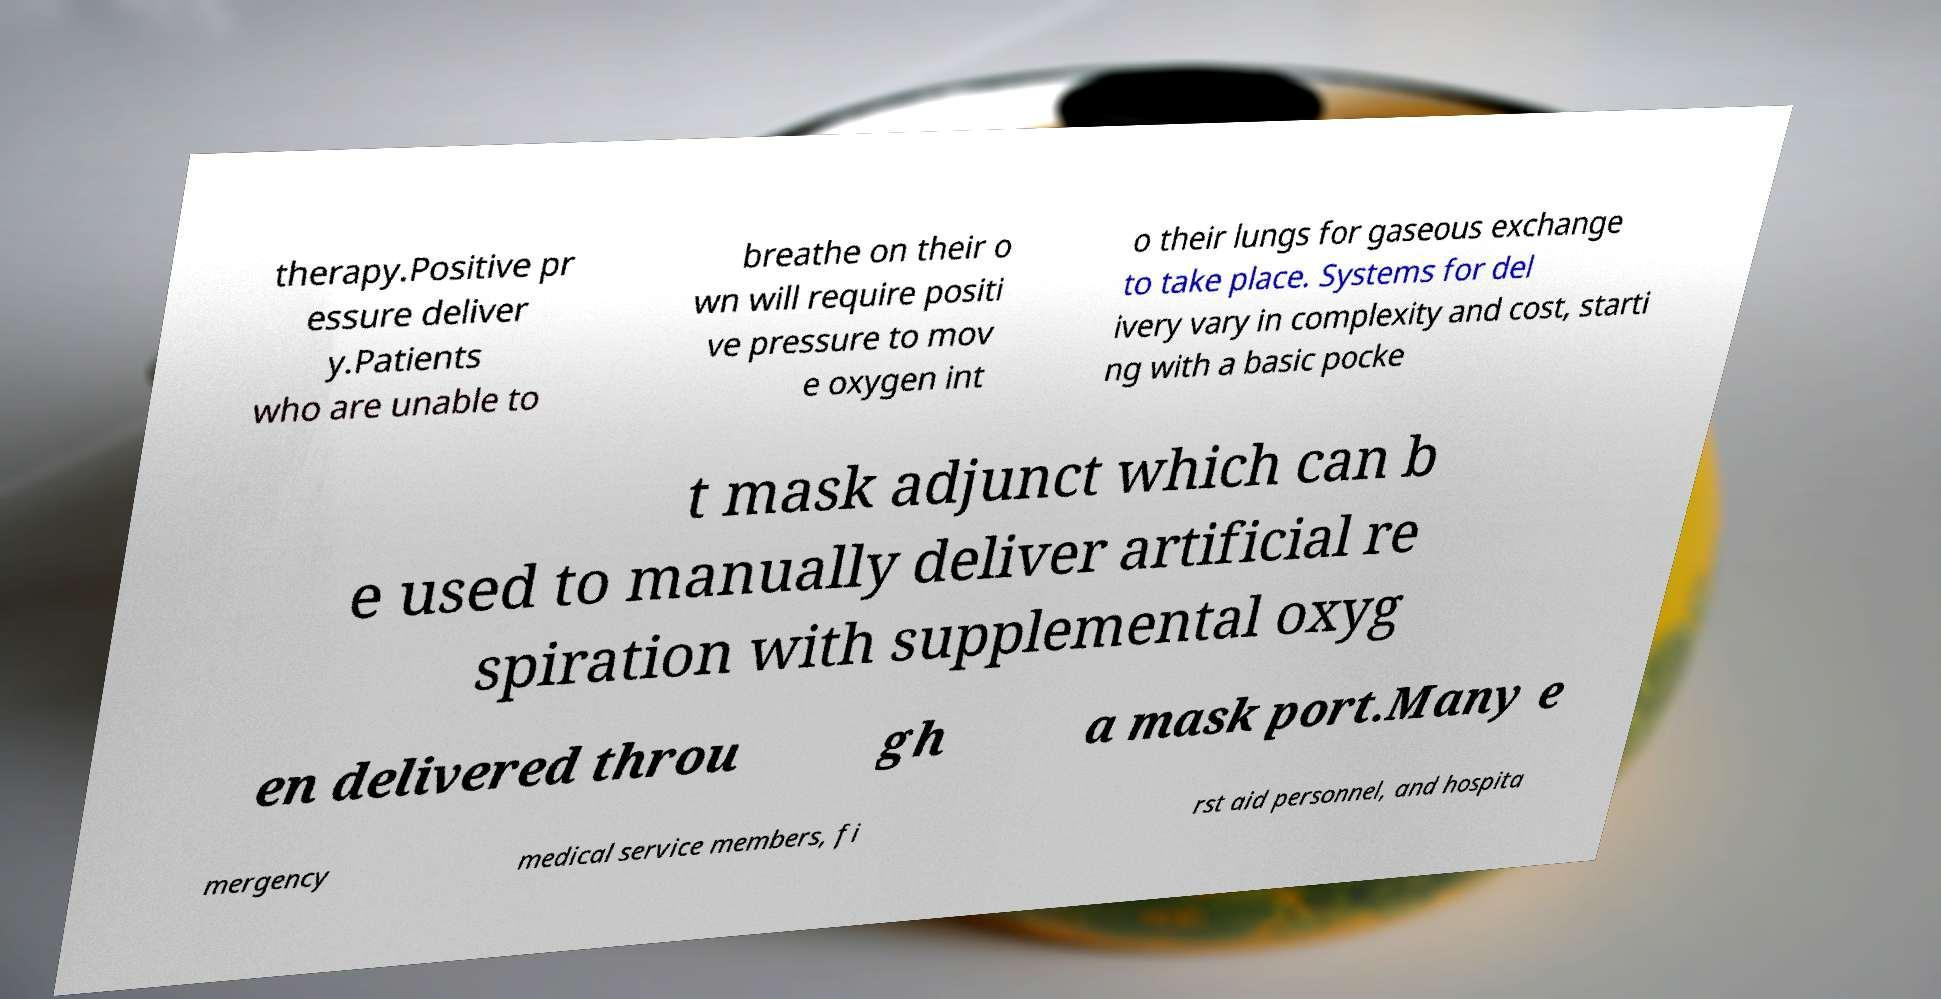There's text embedded in this image that I need extracted. Can you transcribe it verbatim? therapy.Positive pr essure deliver y.Patients who are unable to breathe on their o wn will require positi ve pressure to mov e oxygen int o their lungs for gaseous exchange to take place. Systems for del ivery vary in complexity and cost, starti ng with a basic pocke t mask adjunct which can b e used to manually deliver artificial re spiration with supplemental oxyg en delivered throu gh a mask port.Many e mergency medical service members, fi rst aid personnel, and hospita 